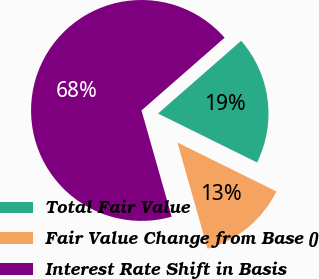<chart> <loc_0><loc_0><loc_500><loc_500><pie_chart><fcel>Total Fair Value<fcel>Fair Value Change from Base ()<fcel>Interest Rate Shift in Basis<nl><fcel>18.75%<fcel>13.29%<fcel>67.96%<nl></chart> 